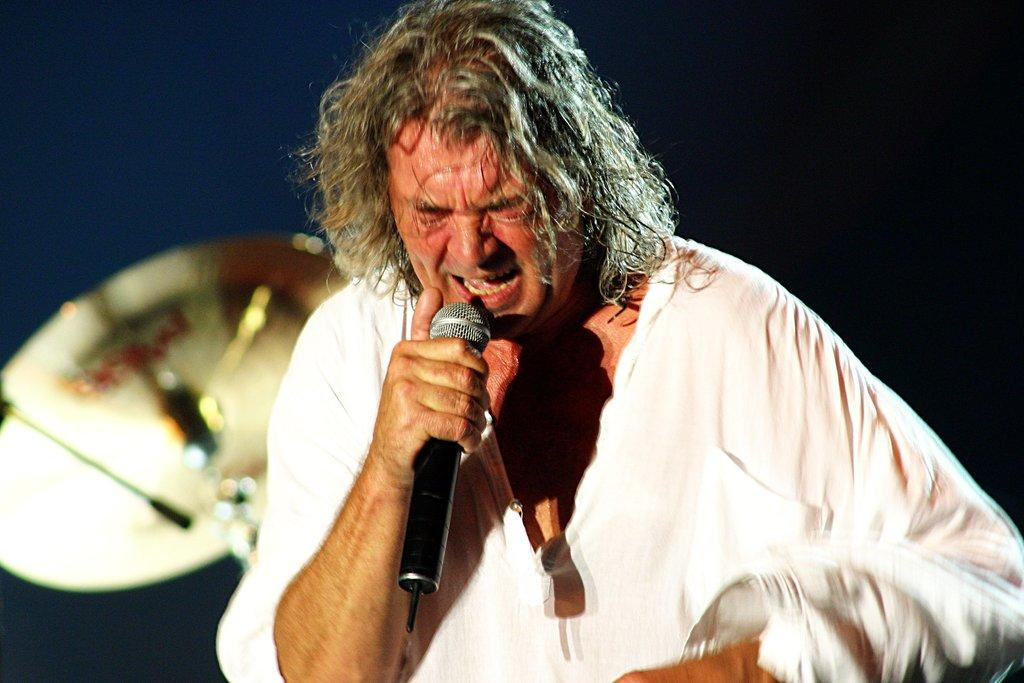What is the main subject of the image? There is a person standing in the image. What is the person holding in his hand? The person is holding a mic in his hand. What other object is visible near the person? There is a musical instrument beside the person. How would you describe the lighting in the image? The background of the image is dark. What type of bubble can be seen floating near the person in the image? There is no bubble present in the image. Can you tell me if the person's friend is also visible in the image? The provided facts do not mention the presence of a friend, so we cannot determine if a friend is visible in the image. 